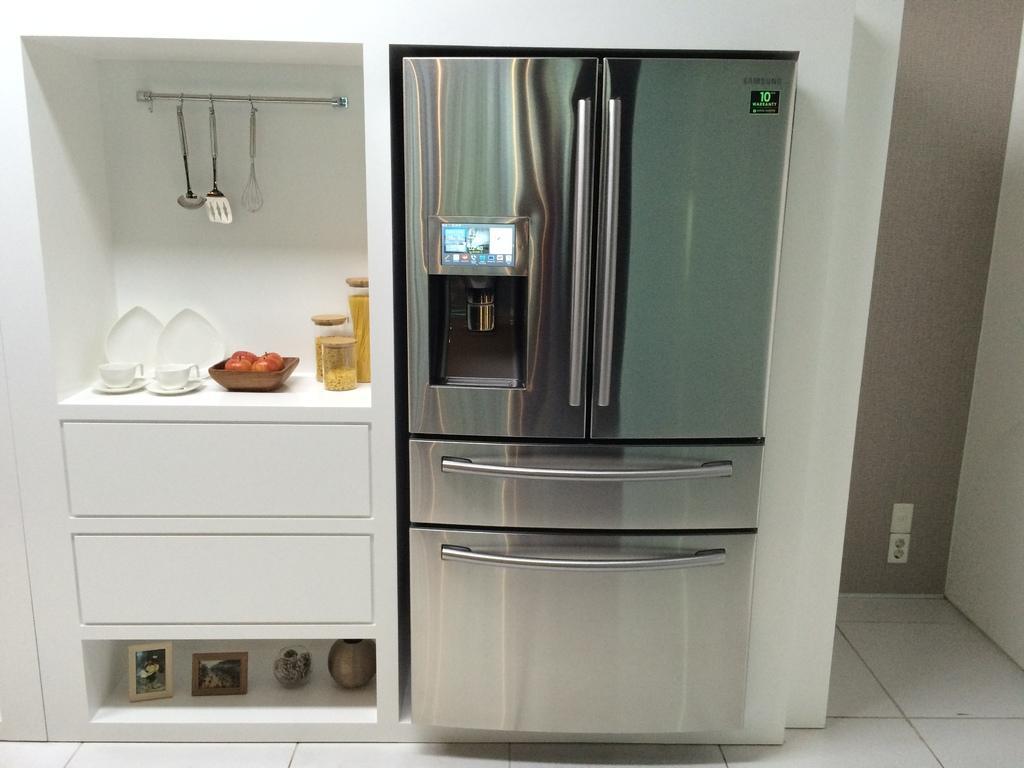How would you summarize this image in a sentence or two? Here in this picture in the middle we can see a refrigerator present and beside that in he racks we can see cups present on saucer and we can also see plates present and we can see apples present in the bowl and we can also see some bottles present and we can see spoons hanging over the place and below that we can see drawers present and we can also see some photo frames present at the bottom. 